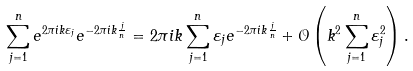<formula> <loc_0><loc_0><loc_500><loc_500>\sum _ { j = 1 } ^ { n } e ^ { 2 \pi i k \varepsilon _ { j } } e ^ { - 2 \pi i k \frac { j } { n } } = 2 \pi i k \sum _ { j = 1 } ^ { n } \varepsilon _ { j } e ^ { - 2 \pi i k \frac { j } { n } } + \mathcal { O } \left ( k ^ { 2 } \sum _ { j = 1 } ^ { n } \varepsilon _ { j } ^ { 2 } \right ) .</formula> 